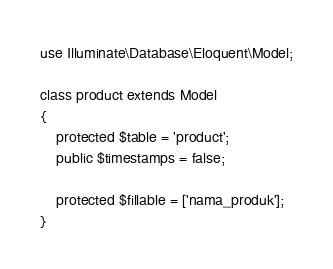Convert code to text. <code><loc_0><loc_0><loc_500><loc_500><_PHP_>
use Illuminate\Database\Eloquent\Model;

class product extends Model
{
    protected $table = 'product';
    public $timestamps = false;

    protected $fillable = ['nama_produk'];
}
</code> 